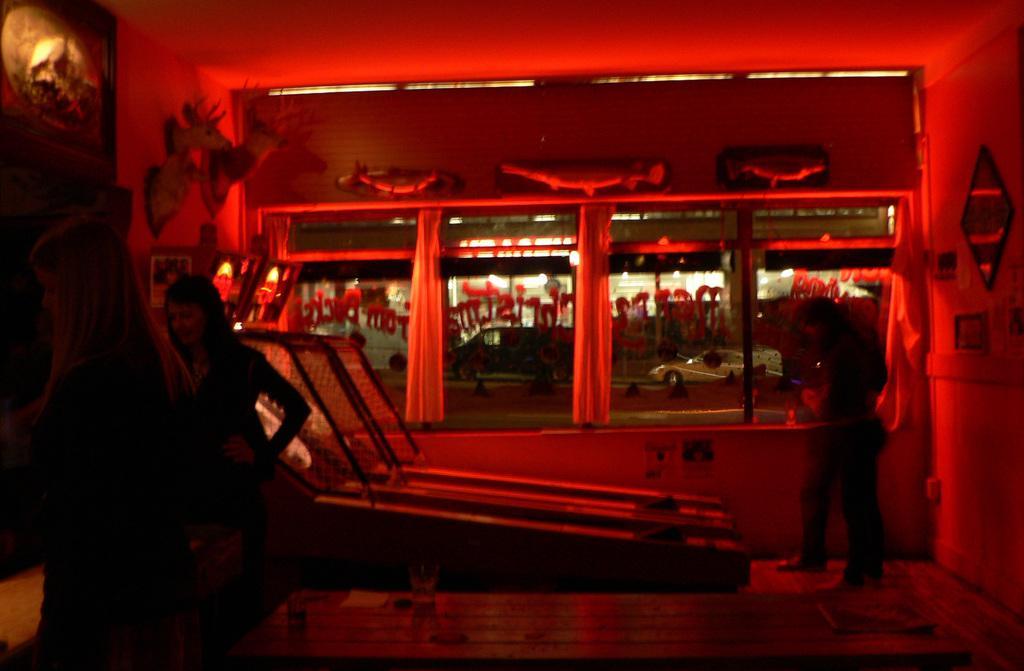Could you give a brief overview of what you see in this image? In this picture I can see few people are standing and I can see glass windows and from the glass I can see building and a car and I can see few curtains and looks like a game in the back and looks like replica of few animal heads. 